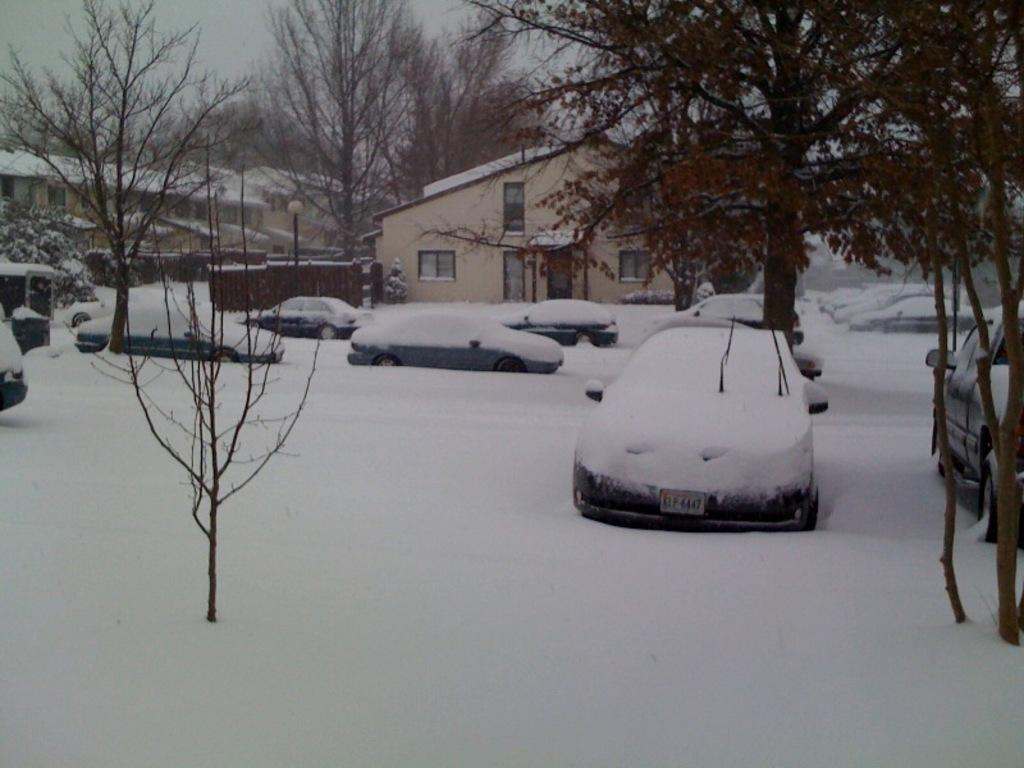What can be seen in the image? There are vehicles in the image, and they are on the snow. What else is visible in the background of the image? There are houses, trees, and the sky visible in the background of the image. What type of salt is being offered by the beast in the image? There is no beast or salt present in the image. 